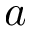<formula> <loc_0><loc_0><loc_500><loc_500>a</formula> 